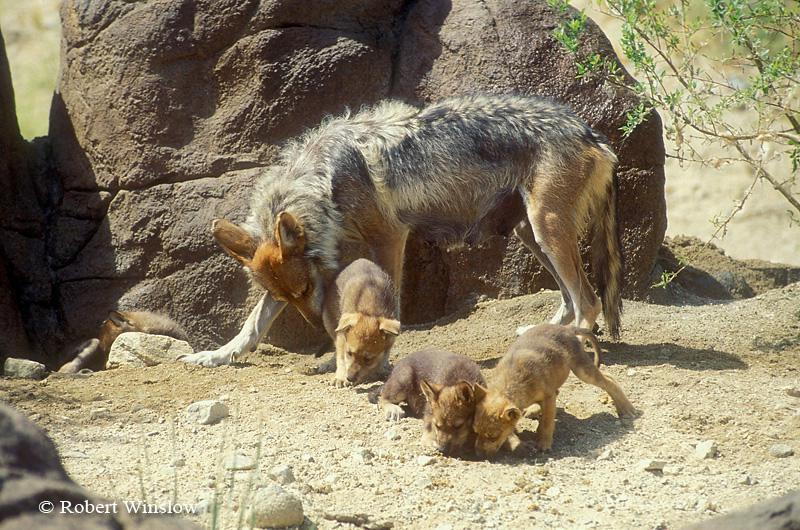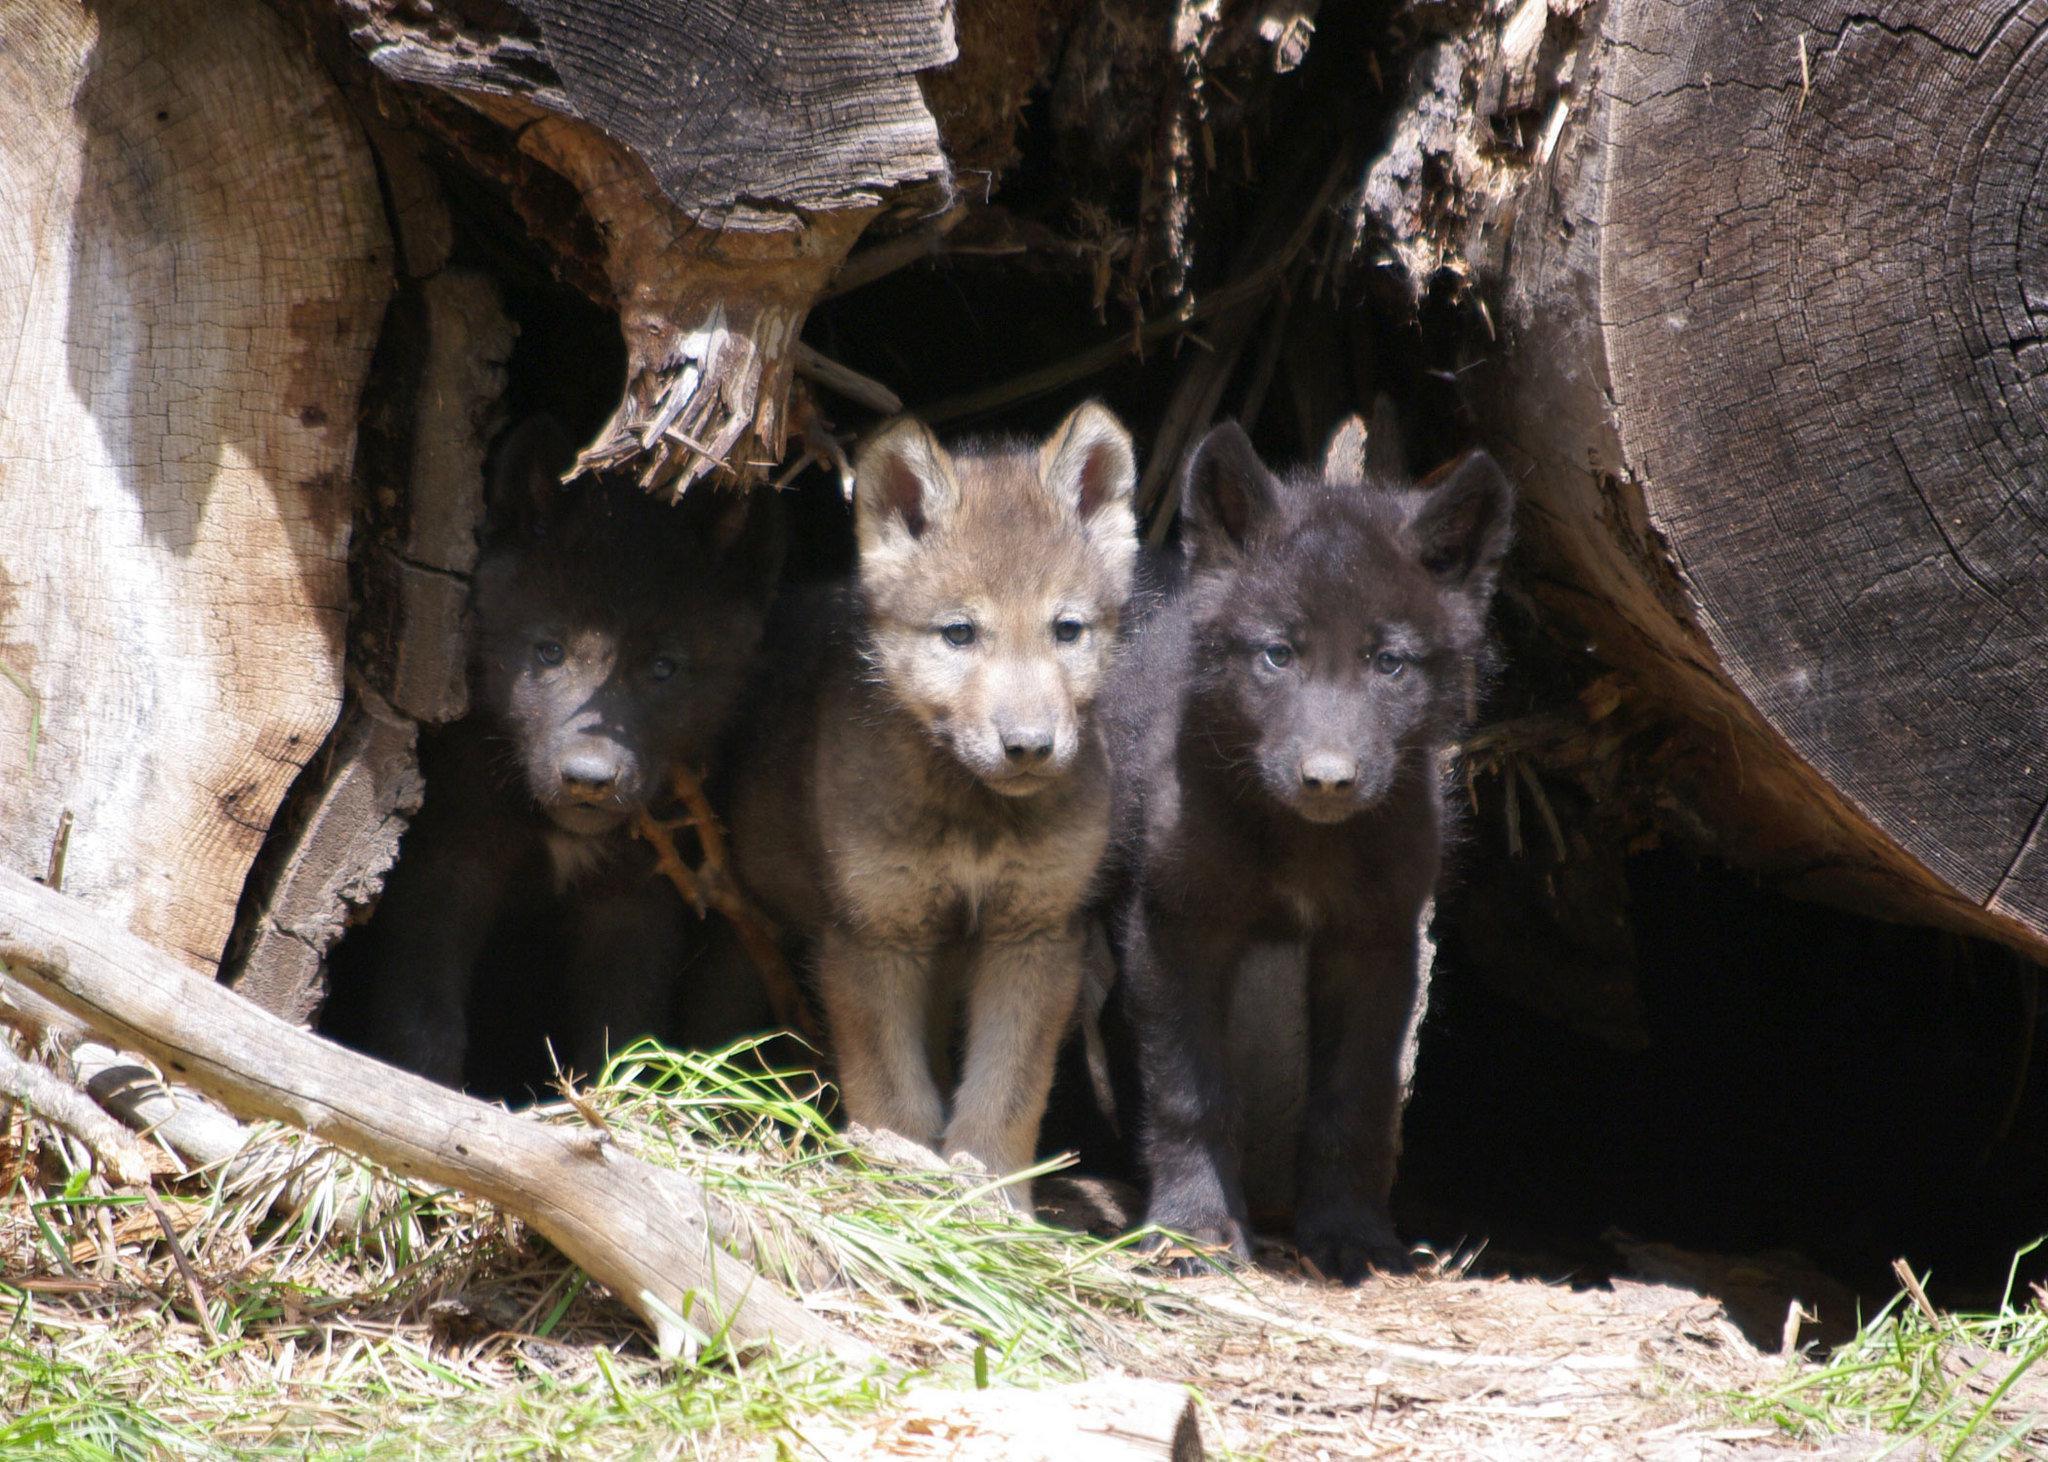The first image is the image on the left, the second image is the image on the right. Examine the images to the left and right. Is the description "There is no more than three wolves in the right image." accurate? Answer yes or no. Yes. The first image is the image on the left, the second image is the image on the right. Assess this claim about the two images: "One image shows at least two forward-facing wolf pups standing side-by-side and no adult wolves, and the other image shows an adult wolf and pups, with its muzzle touching one pup.". Correct or not? Answer yes or no. Yes. 